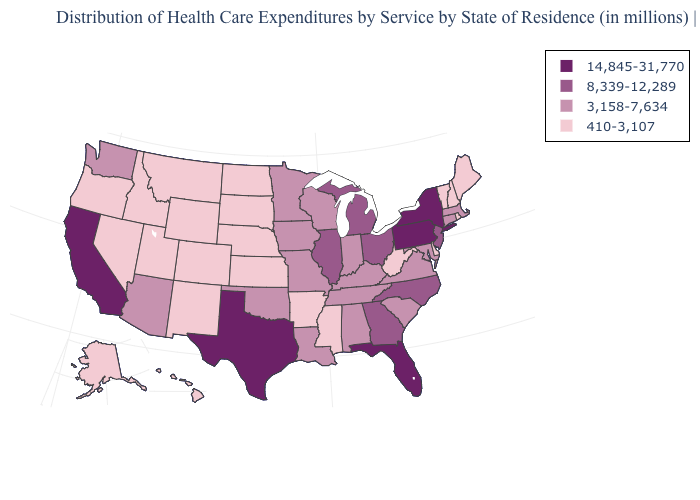Does Pennsylvania have a higher value than Alaska?
Give a very brief answer. Yes. Does Nevada have the same value as Kansas?
Write a very short answer. Yes. Among the states that border Idaho , which have the highest value?
Concise answer only. Washington. What is the lowest value in states that border Vermont?
Give a very brief answer. 410-3,107. Name the states that have a value in the range 3,158-7,634?
Quick response, please. Alabama, Arizona, Connecticut, Indiana, Iowa, Kentucky, Louisiana, Maryland, Massachusetts, Minnesota, Missouri, Oklahoma, South Carolina, Tennessee, Virginia, Washington, Wisconsin. Name the states that have a value in the range 410-3,107?
Keep it brief. Alaska, Arkansas, Colorado, Delaware, Hawaii, Idaho, Kansas, Maine, Mississippi, Montana, Nebraska, Nevada, New Hampshire, New Mexico, North Dakota, Oregon, Rhode Island, South Dakota, Utah, Vermont, West Virginia, Wyoming. Name the states that have a value in the range 3,158-7,634?
Quick response, please. Alabama, Arizona, Connecticut, Indiana, Iowa, Kentucky, Louisiana, Maryland, Massachusetts, Minnesota, Missouri, Oklahoma, South Carolina, Tennessee, Virginia, Washington, Wisconsin. Does the first symbol in the legend represent the smallest category?
Be succinct. No. What is the value of North Carolina?
Quick response, please. 8,339-12,289. Is the legend a continuous bar?
Short answer required. No. What is the value of Maine?
Write a very short answer. 410-3,107. Among the states that border Kentucky , which have the lowest value?
Give a very brief answer. West Virginia. Does Illinois have a lower value than Texas?
Keep it brief. Yes. Does Michigan have a higher value than Louisiana?
Be succinct. Yes. What is the highest value in the South ?
Be succinct. 14,845-31,770. 